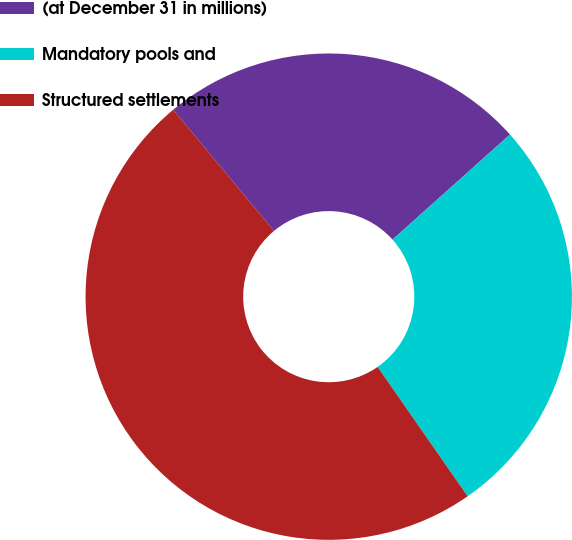<chart> <loc_0><loc_0><loc_500><loc_500><pie_chart><fcel>(at December 31 in millions)<fcel>Mandatory pools and<fcel>Structured settlements<nl><fcel>24.43%<fcel>26.94%<fcel>48.62%<nl></chart> 